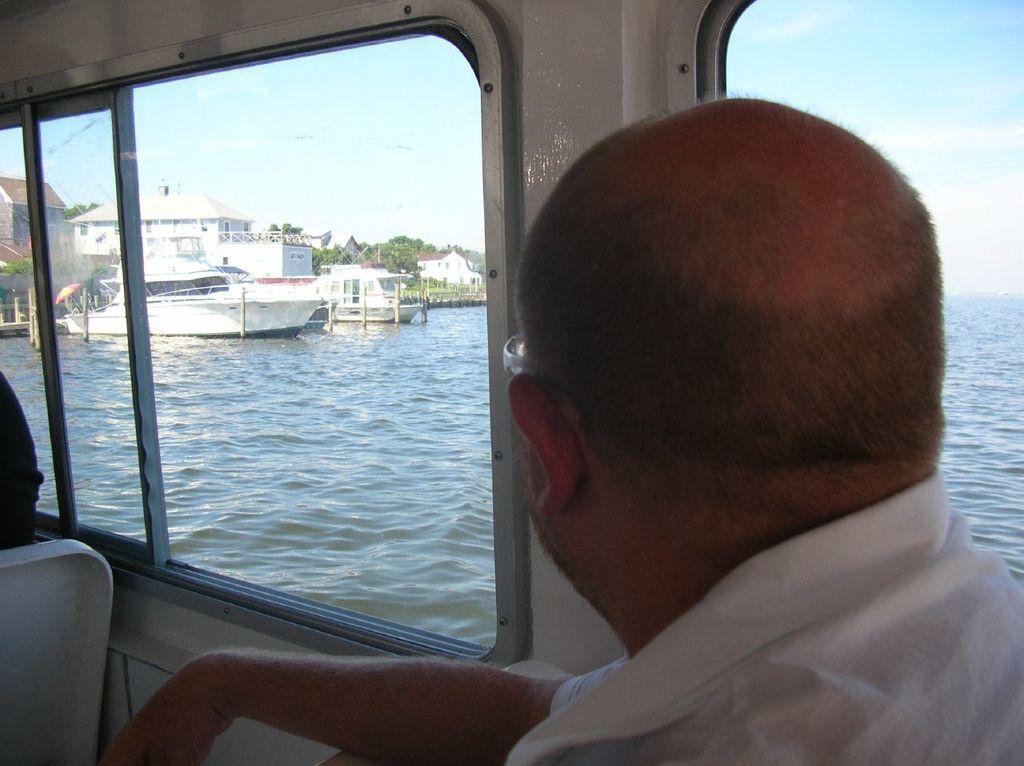In one or two sentences, can you explain what this image depicts? This image is clicked inside a vehicle. There is a man inside the vehicle. Beside the man there are windows. Outside the windows there is the water. There are boats on the water. In the background there are houses and trees. At the top there is the sky. 